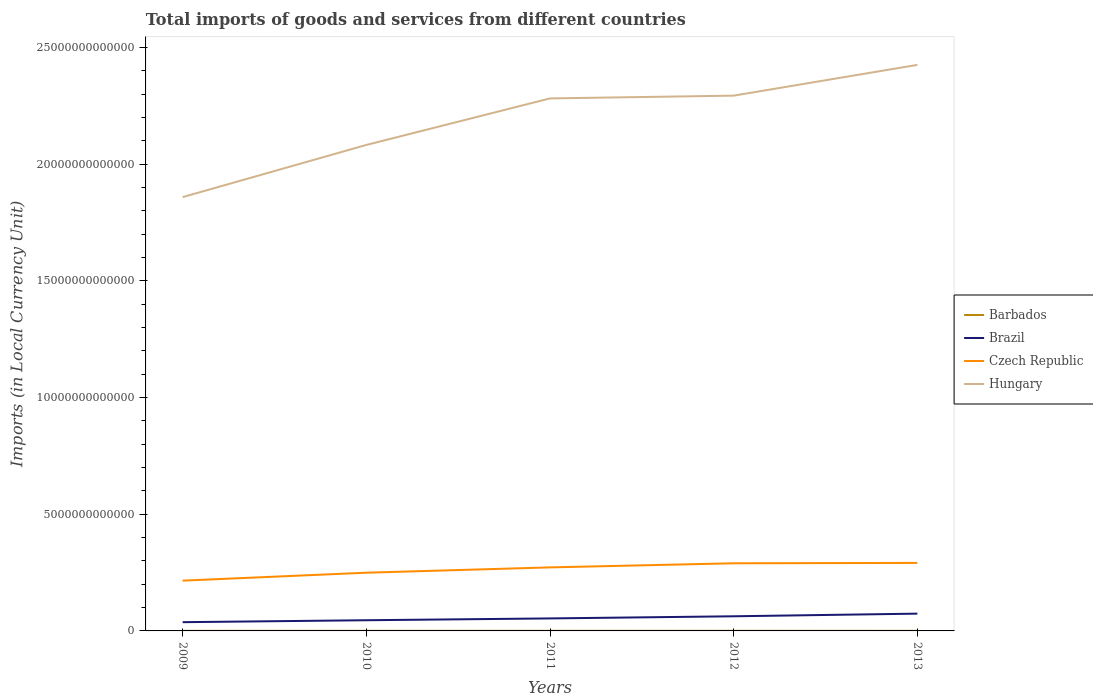Is the number of lines equal to the number of legend labels?
Provide a short and direct response. Yes. Across all years, what is the maximum Amount of goods and services imports in Brazil?
Ensure brevity in your answer.  3.75e+11. In which year was the Amount of goods and services imports in Czech Republic maximum?
Offer a very short reply. 2009. What is the total Amount of goods and services imports in Brazil in the graph?
Make the answer very short. -9.18e+1. What is the difference between the highest and the second highest Amount of goods and services imports in Czech Republic?
Keep it short and to the point. 7.60e+11. What is the difference between the highest and the lowest Amount of goods and services imports in Brazil?
Ensure brevity in your answer.  2. Is the Amount of goods and services imports in Hungary strictly greater than the Amount of goods and services imports in Czech Republic over the years?
Your answer should be compact. No. How many lines are there?
Your response must be concise. 4. How many years are there in the graph?
Ensure brevity in your answer.  5. What is the difference between two consecutive major ticks on the Y-axis?
Make the answer very short. 5.00e+12. Where does the legend appear in the graph?
Offer a very short reply. Center right. How many legend labels are there?
Offer a very short reply. 4. How are the legend labels stacked?
Keep it short and to the point. Vertical. What is the title of the graph?
Your answer should be very brief. Total imports of goods and services from different countries. What is the label or title of the X-axis?
Provide a short and direct response. Years. What is the label or title of the Y-axis?
Your answer should be compact. Imports (in Local Currency Unit). What is the Imports (in Local Currency Unit) in Barbados in 2009?
Provide a succinct answer. 4.09e+09. What is the Imports (in Local Currency Unit) of Brazil in 2009?
Keep it short and to the point. 3.75e+11. What is the Imports (in Local Currency Unit) in Czech Republic in 2009?
Your response must be concise. 2.15e+12. What is the Imports (in Local Currency Unit) of Hungary in 2009?
Provide a short and direct response. 1.86e+13. What is the Imports (in Local Currency Unit) of Barbados in 2010?
Give a very brief answer. 4.48e+09. What is the Imports (in Local Currency Unit) of Brazil in 2010?
Your response must be concise. 4.58e+11. What is the Imports (in Local Currency Unit) of Czech Republic in 2010?
Offer a terse response. 2.49e+12. What is the Imports (in Local Currency Unit) in Hungary in 2010?
Your answer should be very brief. 2.08e+13. What is the Imports (in Local Currency Unit) in Barbados in 2011?
Your response must be concise. 4.57e+09. What is the Imports (in Local Currency Unit) of Brazil in 2011?
Ensure brevity in your answer.  5.35e+11. What is the Imports (in Local Currency Unit) of Czech Republic in 2011?
Your answer should be compact. 2.72e+12. What is the Imports (in Local Currency Unit) in Hungary in 2011?
Provide a short and direct response. 2.28e+13. What is the Imports (in Local Currency Unit) in Barbados in 2012?
Provide a short and direct response. 4.35e+09. What is the Imports (in Local Currency Unit) in Brazil in 2012?
Offer a very short reply. 6.27e+11. What is the Imports (in Local Currency Unit) of Czech Republic in 2012?
Give a very brief answer. 2.90e+12. What is the Imports (in Local Currency Unit) in Hungary in 2012?
Your answer should be very brief. 2.29e+13. What is the Imports (in Local Currency Unit) in Barbados in 2013?
Give a very brief answer. 4.27e+09. What is the Imports (in Local Currency Unit) of Brazil in 2013?
Your answer should be compact. 7.40e+11. What is the Imports (in Local Currency Unit) of Czech Republic in 2013?
Offer a terse response. 2.91e+12. What is the Imports (in Local Currency Unit) of Hungary in 2013?
Provide a succinct answer. 2.42e+13. Across all years, what is the maximum Imports (in Local Currency Unit) of Barbados?
Provide a short and direct response. 4.57e+09. Across all years, what is the maximum Imports (in Local Currency Unit) of Brazil?
Keep it short and to the point. 7.40e+11. Across all years, what is the maximum Imports (in Local Currency Unit) of Czech Republic?
Make the answer very short. 2.91e+12. Across all years, what is the maximum Imports (in Local Currency Unit) in Hungary?
Your response must be concise. 2.42e+13. Across all years, what is the minimum Imports (in Local Currency Unit) in Barbados?
Give a very brief answer. 4.09e+09. Across all years, what is the minimum Imports (in Local Currency Unit) in Brazil?
Give a very brief answer. 3.75e+11. Across all years, what is the minimum Imports (in Local Currency Unit) in Czech Republic?
Give a very brief answer. 2.15e+12. Across all years, what is the minimum Imports (in Local Currency Unit) of Hungary?
Offer a very short reply. 1.86e+13. What is the total Imports (in Local Currency Unit) of Barbados in the graph?
Give a very brief answer. 2.18e+1. What is the total Imports (in Local Currency Unit) of Brazil in the graph?
Give a very brief answer. 2.74e+12. What is the total Imports (in Local Currency Unit) in Czech Republic in the graph?
Provide a succinct answer. 1.32e+13. What is the total Imports (in Local Currency Unit) of Hungary in the graph?
Keep it short and to the point. 1.09e+14. What is the difference between the Imports (in Local Currency Unit) of Barbados in 2009 and that in 2010?
Your answer should be very brief. -3.89e+08. What is the difference between the Imports (in Local Currency Unit) of Brazil in 2009 and that in 2010?
Your answer should be compact. -8.26e+1. What is the difference between the Imports (in Local Currency Unit) of Czech Republic in 2009 and that in 2010?
Your response must be concise. -3.40e+11. What is the difference between the Imports (in Local Currency Unit) of Hungary in 2009 and that in 2010?
Keep it short and to the point. -2.23e+12. What is the difference between the Imports (in Local Currency Unit) in Barbados in 2009 and that in 2011?
Ensure brevity in your answer.  -4.83e+08. What is the difference between the Imports (in Local Currency Unit) in Brazil in 2009 and that in 2011?
Ensure brevity in your answer.  -1.60e+11. What is the difference between the Imports (in Local Currency Unit) of Czech Republic in 2009 and that in 2011?
Provide a succinct answer. -5.68e+11. What is the difference between the Imports (in Local Currency Unit) of Hungary in 2009 and that in 2011?
Give a very brief answer. -4.23e+12. What is the difference between the Imports (in Local Currency Unit) of Barbados in 2009 and that in 2012?
Provide a succinct answer. -2.60e+08. What is the difference between the Imports (in Local Currency Unit) of Brazil in 2009 and that in 2012?
Offer a terse response. -2.52e+11. What is the difference between the Imports (in Local Currency Unit) of Czech Republic in 2009 and that in 2012?
Ensure brevity in your answer.  -7.43e+11. What is the difference between the Imports (in Local Currency Unit) in Hungary in 2009 and that in 2012?
Your response must be concise. -4.35e+12. What is the difference between the Imports (in Local Currency Unit) of Barbados in 2009 and that in 2013?
Your response must be concise. -1.83e+08. What is the difference between the Imports (in Local Currency Unit) of Brazil in 2009 and that in 2013?
Offer a very short reply. -3.65e+11. What is the difference between the Imports (in Local Currency Unit) of Czech Republic in 2009 and that in 2013?
Offer a terse response. -7.60e+11. What is the difference between the Imports (in Local Currency Unit) of Hungary in 2009 and that in 2013?
Ensure brevity in your answer.  -5.67e+12. What is the difference between the Imports (in Local Currency Unit) in Barbados in 2010 and that in 2011?
Offer a very short reply. -9.40e+07. What is the difference between the Imports (in Local Currency Unit) in Brazil in 2010 and that in 2011?
Offer a terse response. -7.78e+1. What is the difference between the Imports (in Local Currency Unit) of Czech Republic in 2010 and that in 2011?
Offer a terse response. -2.28e+11. What is the difference between the Imports (in Local Currency Unit) in Hungary in 2010 and that in 2011?
Keep it short and to the point. -1.99e+12. What is the difference between the Imports (in Local Currency Unit) of Barbados in 2010 and that in 2012?
Ensure brevity in your answer.  1.29e+08. What is the difference between the Imports (in Local Currency Unit) of Brazil in 2010 and that in 2012?
Your response must be concise. -1.70e+11. What is the difference between the Imports (in Local Currency Unit) of Czech Republic in 2010 and that in 2012?
Make the answer very short. -4.04e+11. What is the difference between the Imports (in Local Currency Unit) of Hungary in 2010 and that in 2012?
Ensure brevity in your answer.  -2.11e+12. What is the difference between the Imports (in Local Currency Unit) in Barbados in 2010 and that in 2013?
Your response must be concise. 2.06e+08. What is the difference between the Imports (in Local Currency Unit) in Brazil in 2010 and that in 2013?
Make the answer very short. -2.83e+11. What is the difference between the Imports (in Local Currency Unit) of Czech Republic in 2010 and that in 2013?
Give a very brief answer. -4.20e+11. What is the difference between the Imports (in Local Currency Unit) in Hungary in 2010 and that in 2013?
Give a very brief answer. -3.43e+12. What is the difference between the Imports (in Local Currency Unit) in Barbados in 2011 and that in 2012?
Make the answer very short. 2.23e+08. What is the difference between the Imports (in Local Currency Unit) in Brazil in 2011 and that in 2012?
Make the answer very short. -9.18e+1. What is the difference between the Imports (in Local Currency Unit) of Czech Republic in 2011 and that in 2012?
Your answer should be very brief. -1.76e+11. What is the difference between the Imports (in Local Currency Unit) of Hungary in 2011 and that in 2012?
Make the answer very short. -1.19e+11. What is the difference between the Imports (in Local Currency Unit) of Barbados in 2011 and that in 2013?
Make the answer very short. 3.00e+08. What is the difference between the Imports (in Local Currency Unit) of Brazil in 2011 and that in 2013?
Ensure brevity in your answer.  -2.05e+11. What is the difference between the Imports (in Local Currency Unit) in Czech Republic in 2011 and that in 2013?
Your answer should be compact. -1.92e+11. What is the difference between the Imports (in Local Currency Unit) of Hungary in 2011 and that in 2013?
Ensure brevity in your answer.  -1.44e+12. What is the difference between the Imports (in Local Currency Unit) in Barbados in 2012 and that in 2013?
Keep it short and to the point. 7.70e+07. What is the difference between the Imports (in Local Currency Unit) of Brazil in 2012 and that in 2013?
Your answer should be compact. -1.13e+11. What is the difference between the Imports (in Local Currency Unit) in Czech Republic in 2012 and that in 2013?
Your answer should be very brief. -1.66e+1. What is the difference between the Imports (in Local Currency Unit) of Hungary in 2012 and that in 2013?
Ensure brevity in your answer.  -1.32e+12. What is the difference between the Imports (in Local Currency Unit) in Barbados in 2009 and the Imports (in Local Currency Unit) in Brazil in 2010?
Offer a very short reply. -4.54e+11. What is the difference between the Imports (in Local Currency Unit) of Barbados in 2009 and the Imports (in Local Currency Unit) of Czech Republic in 2010?
Offer a terse response. -2.49e+12. What is the difference between the Imports (in Local Currency Unit) in Barbados in 2009 and the Imports (in Local Currency Unit) in Hungary in 2010?
Ensure brevity in your answer.  -2.08e+13. What is the difference between the Imports (in Local Currency Unit) in Brazil in 2009 and the Imports (in Local Currency Unit) in Czech Republic in 2010?
Give a very brief answer. -2.12e+12. What is the difference between the Imports (in Local Currency Unit) of Brazil in 2009 and the Imports (in Local Currency Unit) of Hungary in 2010?
Offer a very short reply. -2.04e+13. What is the difference between the Imports (in Local Currency Unit) in Czech Republic in 2009 and the Imports (in Local Currency Unit) in Hungary in 2010?
Keep it short and to the point. -1.87e+13. What is the difference between the Imports (in Local Currency Unit) in Barbados in 2009 and the Imports (in Local Currency Unit) in Brazil in 2011?
Offer a terse response. -5.31e+11. What is the difference between the Imports (in Local Currency Unit) of Barbados in 2009 and the Imports (in Local Currency Unit) of Czech Republic in 2011?
Provide a succinct answer. -2.72e+12. What is the difference between the Imports (in Local Currency Unit) of Barbados in 2009 and the Imports (in Local Currency Unit) of Hungary in 2011?
Provide a short and direct response. -2.28e+13. What is the difference between the Imports (in Local Currency Unit) of Brazil in 2009 and the Imports (in Local Currency Unit) of Czech Republic in 2011?
Offer a terse response. -2.35e+12. What is the difference between the Imports (in Local Currency Unit) of Brazil in 2009 and the Imports (in Local Currency Unit) of Hungary in 2011?
Keep it short and to the point. -2.24e+13. What is the difference between the Imports (in Local Currency Unit) in Czech Republic in 2009 and the Imports (in Local Currency Unit) in Hungary in 2011?
Offer a terse response. -2.07e+13. What is the difference between the Imports (in Local Currency Unit) of Barbados in 2009 and the Imports (in Local Currency Unit) of Brazil in 2012?
Provide a short and direct response. -6.23e+11. What is the difference between the Imports (in Local Currency Unit) of Barbados in 2009 and the Imports (in Local Currency Unit) of Czech Republic in 2012?
Your response must be concise. -2.89e+12. What is the difference between the Imports (in Local Currency Unit) in Barbados in 2009 and the Imports (in Local Currency Unit) in Hungary in 2012?
Your answer should be very brief. -2.29e+13. What is the difference between the Imports (in Local Currency Unit) in Brazil in 2009 and the Imports (in Local Currency Unit) in Czech Republic in 2012?
Keep it short and to the point. -2.52e+12. What is the difference between the Imports (in Local Currency Unit) of Brazil in 2009 and the Imports (in Local Currency Unit) of Hungary in 2012?
Ensure brevity in your answer.  -2.26e+13. What is the difference between the Imports (in Local Currency Unit) in Czech Republic in 2009 and the Imports (in Local Currency Unit) in Hungary in 2012?
Offer a very short reply. -2.08e+13. What is the difference between the Imports (in Local Currency Unit) of Barbados in 2009 and the Imports (in Local Currency Unit) of Brazil in 2013?
Make the answer very short. -7.36e+11. What is the difference between the Imports (in Local Currency Unit) in Barbados in 2009 and the Imports (in Local Currency Unit) in Czech Republic in 2013?
Your answer should be compact. -2.91e+12. What is the difference between the Imports (in Local Currency Unit) of Barbados in 2009 and the Imports (in Local Currency Unit) of Hungary in 2013?
Make the answer very short. -2.42e+13. What is the difference between the Imports (in Local Currency Unit) in Brazil in 2009 and the Imports (in Local Currency Unit) in Czech Republic in 2013?
Your response must be concise. -2.54e+12. What is the difference between the Imports (in Local Currency Unit) of Brazil in 2009 and the Imports (in Local Currency Unit) of Hungary in 2013?
Make the answer very short. -2.39e+13. What is the difference between the Imports (in Local Currency Unit) of Czech Republic in 2009 and the Imports (in Local Currency Unit) of Hungary in 2013?
Your answer should be very brief. -2.21e+13. What is the difference between the Imports (in Local Currency Unit) of Barbados in 2010 and the Imports (in Local Currency Unit) of Brazil in 2011?
Provide a short and direct response. -5.31e+11. What is the difference between the Imports (in Local Currency Unit) in Barbados in 2010 and the Imports (in Local Currency Unit) in Czech Republic in 2011?
Provide a short and direct response. -2.72e+12. What is the difference between the Imports (in Local Currency Unit) of Barbados in 2010 and the Imports (in Local Currency Unit) of Hungary in 2011?
Make the answer very short. -2.28e+13. What is the difference between the Imports (in Local Currency Unit) in Brazil in 2010 and the Imports (in Local Currency Unit) in Czech Republic in 2011?
Keep it short and to the point. -2.26e+12. What is the difference between the Imports (in Local Currency Unit) in Brazil in 2010 and the Imports (in Local Currency Unit) in Hungary in 2011?
Offer a very short reply. -2.24e+13. What is the difference between the Imports (in Local Currency Unit) in Czech Republic in 2010 and the Imports (in Local Currency Unit) in Hungary in 2011?
Your answer should be very brief. -2.03e+13. What is the difference between the Imports (in Local Currency Unit) in Barbados in 2010 and the Imports (in Local Currency Unit) in Brazil in 2012?
Offer a terse response. -6.23e+11. What is the difference between the Imports (in Local Currency Unit) of Barbados in 2010 and the Imports (in Local Currency Unit) of Czech Republic in 2012?
Provide a short and direct response. -2.89e+12. What is the difference between the Imports (in Local Currency Unit) of Barbados in 2010 and the Imports (in Local Currency Unit) of Hungary in 2012?
Your response must be concise. -2.29e+13. What is the difference between the Imports (in Local Currency Unit) of Brazil in 2010 and the Imports (in Local Currency Unit) of Czech Republic in 2012?
Your response must be concise. -2.44e+12. What is the difference between the Imports (in Local Currency Unit) of Brazil in 2010 and the Imports (in Local Currency Unit) of Hungary in 2012?
Provide a succinct answer. -2.25e+13. What is the difference between the Imports (in Local Currency Unit) in Czech Republic in 2010 and the Imports (in Local Currency Unit) in Hungary in 2012?
Give a very brief answer. -2.04e+13. What is the difference between the Imports (in Local Currency Unit) in Barbados in 2010 and the Imports (in Local Currency Unit) in Brazil in 2013?
Provide a succinct answer. -7.36e+11. What is the difference between the Imports (in Local Currency Unit) in Barbados in 2010 and the Imports (in Local Currency Unit) in Czech Republic in 2013?
Provide a succinct answer. -2.91e+12. What is the difference between the Imports (in Local Currency Unit) of Barbados in 2010 and the Imports (in Local Currency Unit) of Hungary in 2013?
Your answer should be very brief. -2.42e+13. What is the difference between the Imports (in Local Currency Unit) in Brazil in 2010 and the Imports (in Local Currency Unit) in Czech Republic in 2013?
Your response must be concise. -2.46e+12. What is the difference between the Imports (in Local Currency Unit) in Brazil in 2010 and the Imports (in Local Currency Unit) in Hungary in 2013?
Make the answer very short. -2.38e+13. What is the difference between the Imports (in Local Currency Unit) of Czech Republic in 2010 and the Imports (in Local Currency Unit) of Hungary in 2013?
Offer a terse response. -2.18e+13. What is the difference between the Imports (in Local Currency Unit) of Barbados in 2011 and the Imports (in Local Currency Unit) of Brazil in 2012?
Your response must be concise. -6.23e+11. What is the difference between the Imports (in Local Currency Unit) of Barbados in 2011 and the Imports (in Local Currency Unit) of Czech Republic in 2012?
Make the answer very short. -2.89e+12. What is the difference between the Imports (in Local Currency Unit) of Barbados in 2011 and the Imports (in Local Currency Unit) of Hungary in 2012?
Keep it short and to the point. -2.29e+13. What is the difference between the Imports (in Local Currency Unit) in Brazil in 2011 and the Imports (in Local Currency Unit) in Czech Republic in 2012?
Offer a very short reply. -2.36e+12. What is the difference between the Imports (in Local Currency Unit) in Brazil in 2011 and the Imports (in Local Currency Unit) in Hungary in 2012?
Give a very brief answer. -2.24e+13. What is the difference between the Imports (in Local Currency Unit) in Czech Republic in 2011 and the Imports (in Local Currency Unit) in Hungary in 2012?
Give a very brief answer. -2.02e+13. What is the difference between the Imports (in Local Currency Unit) in Barbados in 2011 and the Imports (in Local Currency Unit) in Brazil in 2013?
Your answer should be very brief. -7.36e+11. What is the difference between the Imports (in Local Currency Unit) of Barbados in 2011 and the Imports (in Local Currency Unit) of Czech Republic in 2013?
Provide a succinct answer. -2.91e+12. What is the difference between the Imports (in Local Currency Unit) in Barbados in 2011 and the Imports (in Local Currency Unit) in Hungary in 2013?
Provide a short and direct response. -2.42e+13. What is the difference between the Imports (in Local Currency Unit) of Brazil in 2011 and the Imports (in Local Currency Unit) of Czech Republic in 2013?
Offer a terse response. -2.38e+12. What is the difference between the Imports (in Local Currency Unit) in Brazil in 2011 and the Imports (in Local Currency Unit) in Hungary in 2013?
Ensure brevity in your answer.  -2.37e+13. What is the difference between the Imports (in Local Currency Unit) of Czech Republic in 2011 and the Imports (in Local Currency Unit) of Hungary in 2013?
Your response must be concise. -2.15e+13. What is the difference between the Imports (in Local Currency Unit) in Barbados in 2012 and the Imports (in Local Currency Unit) in Brazil in 2013?
Ensure brevity in your answer.  -7.36e+11. What is the difference between the Imports (in Local Currency Unit) in Barbados in 2012 and the Imports (in Local Currency Unit) in Czech Republic in 2013?
Provide a succinct answer. -2.91e+12. What is the difference between the Imports (in Local Currency Unit) of Barbados in 2012 and the Imports (in Local Currency Unit) of Hungary in 2013?
Make the answer very short. -2.42e+13. What is the difference between the Imports (in Local Currency Unit) of Brazil in 2012 and the Imports (in Local Currency Unit) of Czech Republic in 2013?
Your answer should be very brief. -2.29e+12. What is the difference between the Imports (in Local Currency Unit) in Brazil in 2012 and the Imports (in Local Currency Unit) in Hungary in 2013?
Your answer should be compact. -2.36e+13. What is the difference between the Imports (in Local Currency Unit) of Czech Republic in 2012 and the Imports (in Local Currency Unit) of Hungary in 2013?
Offer a very short reply. -2.14e+13. What is the average Imports (in Local Currency Unit) of Barbados per year?
Provide a short and direct response. 4.35e+09. What is the average Imports (in Local Currency Unit) in Brazil per year?
Make the answer very short. 5.47e+11. What is the average Imports (in Local Currency Unit) in Czech Republic per year?
Provide a short and direct response. 2.64e+12. What is the average Imports (in Local Currency Unit) in Hungary per year?
Provide a short and direct response. 2.19e+13. In the year 2009, what is the difference between the Imports (in Local Currency Unit) of Barbados and Imports (in Local Currency Unit) of Brazil?
Provide a short and direct response. -3.71e+11. In the year 2009, what is the difference between the Imports (in Local Currency Unit) of Barbados and Imports (in Local Currency Unit) of Czech Republic?
Keep it short and to the point. -2.15e+12. In the year 2009, what is the difference between the Imports (in Local Currency Unit) in Barbados and Imports (in Local Currency Unit) in Hungary?
Keep it short and to the point. -1.86e+13. In the year 2009, what is the difference between the Imports (in Local Currency Unit) of Brazil and Imports (in Local Currency Unit) of Czech Republic?
Ensure brevity in your answer.  -1.78e+12. In the year 2009, what is the difference between the Imports (in Local Currency Unit) of Brazil and Imports (in Local Currency Unit) of Hungary?
Keep it short and to the point. -1.82e+13. In the year 2009, what is the difference between the Imports (in Local Currency Unit) in Czech Republic and Imports (in Local Currency Unit) in Hungary?
Offer a terse response. -1.64e+13. In the year 2010, what is the difference between the Imports (in Local Currency Unit) in Barbados and Imports (in Local Currency Unit) in Brazil?
Provide a short and direct response. -4.53e+11. In the year 2010, what is the difference between the Imports (in Local Currency Unit) in Barbados and Imports (in Local Currency Unit) in Czech Republic?
Give a very brief answer. -2.49e+12. In the year 2010, what is the difference between the Imports (in Local Currency Unit) in Barbados and Imports (in Local Currency Unit) in Hungary?
Provide a succinct answer. -2.08e+13. In the year 2010, what is the difference between the Imports (in Local Currency Unit) of Brazil and Imports (in Local Currency Unit) of Czech Republic?
Offer a very short reply. -2.04e+12. In the year 2010, what is the difference between the Imports (in Local Currency Unit) of Brazil and Imports (in Local Currency Unit) of Hungary?
Offer a terse response. -2.04e+13. In the year 2010, what is the difference between the Imports (in Local Currency Unit) in Czech Republic and Imports (in Local Currency Unit) in Hungary?
Provide a succinct answer. -1.83e+13. In the year 2011, what is the difference between the Imports (in Local Currency Unit) in Barbados and Imports (in Local Currency Unit) in Brazil?
Make the answer very short. -5.31e+11. In the year 2011, what is the difference between the Imports (in Local Currency Unit) of Barbados and Imports (in Local Currency Unit) of Czech Republic?
Provide a short and direct response. -2.72e+12. In the year 2011, what is the difference between the Imports (in Local Currency Unit) in Barbados and Imports (in Local Currency Unit) in Hungary?
Keep it short and to the point. -2.28e+13. In the year 2011, what is the difference between the Imports (in Local Currency Unit) in Brazil and Imports (in Local Currency Unit) in Czech Republic?
Your response must be concise. -2.19e+12. In the year 2011, what is the difference between the Imports (in Local Currency Unit) of Brazil and Imports (in Local Currency Unit) of Hungary?
Provide a short and direct response. -2.23e+13. In the year 2011, what is the difference between the Imports (in Local Currency Unit) of Czech Republic and Imports (in Local Currency Unit) of Hungary?
Make the answer very short. -2.01e+13. In the year 2012, what is the difference between the Imports (in Local Currency Unit) of Barbados and Imports (in Local Currency Unit) of Brazil?
Offer a very short reply. -6.23e+11. In the year 2012, what is the difference between the Imports (in Local Currency Unit) of Barbados and Imports (in Local Currency Unit) of Czech Republic?
Provide a succinct answer. -2.89e+12. In the year 2012, what is the difference between the Imports (in Local Currency Unit) in Barbados and Imports (in Local Currency Unit) in Hungary?
Offer a very short reply. -2.29e+13. In the year 2012, what is the difference between the Imports (in Local Currency Unit) in Brazil and Imports (in Local Currency Unit) in Czech Republic?
Your answer should be compact. -2.27e+12. In the year 2012, what is the difference between the Imports (in Local Currency Unit) in Brazil and Imports (in Local Currency Unit) in Hungary?
Make the answer very short. -2.23e+13. In the year 2012, what is the difference between the Imports (in Local Currency Unit) in Czech Republic and Imports (in Local Currency Unit) in Hungary?
Make the answer very short. -2.00e+13. In the year 2013, what is the difference between the Imports (in Local Currency Unit) in Barbados and Imports (in Local Currency Unit) in Brazil?
Make the answer very short. -7.36e+11. In the year 2013, what is the difference between the Imports (in Local Currency Unit) of Barbados and Imports (in Local Currency Unit) of Czech Republic?
Your answer should be compact. -2.91e+12. In the year 2013, what is the difference between the Imports (in Local Currency Unit) in Barbados and Imports (in Local Currency Unit) in Hungary?
Give a very brief answer. -2.42e+13. In the year 2013, what is the difference between the Imports (in Local Currency Unit) of Brazil and Imports (in Local Currency Unit) of Czech Republic?
Your answer should be very brief. -2.17e+12. In the year 2013, what is the difference between the Imports (in Local Currency Unit) in Brazil and Imports (in Local Currency Unit) in Hungary?
Your response must be concise. -2.35e+13. In the year 2013, what is the difference between the Imports (in Local Currency Unit) of Czech Republic and Imports (in Local Currency Unit) of Hungary?
Ensure brevity in your answer.  -2.13e+13. What is the ratio of the Imports (in Local Currency Unit) of Barbados in 2009 to that in 2010?
Your answer should be compact. 0.91. What is the ratio of the Imports (in Local Currency Unit) of Brazil in 2009 to that in 2010?
Give a very brief answer. 0.82. What is the ratio of the Imports (in Local Currency Unit) in Czech Republic in 2009 to that in 2010?
Make the answer very short. 0.86. What is the ratio of the Imports (in Local Currency Unit) of Hungary in 2009 to that in 2010?
Provide a short and direct response. 0.89. What is the ratio of the Imports (in Local Currency Unit) of Barbados in 2009 to that in 2011?
Offer a very short reply. 0.89. What is the ratio of the Imports (in Local Currency Unit) of Brazil in 2009 to that in 2011?
Keep it short and to the point. 0.7. What is the ratio of the Imports (in Local Currency Unit) of Czech Republic in 2009 to that in 2011?
Keep it short and to the point. 0.79. What is the ratio of the Imports (in Local Currency Unit) in Hungary in 2009 to that in 2011?
Offer a terse response. 0.81. What is the ratio of the Imports (in Local Currency Unit) of Barbados in 2009 to that in 2012?
Make the answer very short. 0.94. What is the ratio of the Imports (in Local Currency Unit) of Brazil in 2009 to that in 2012?
Make the answer very short. 0.6. What is the ratio of the Imports (in Local Currency Unit) in Czech Republic in 2009 to that in 2012?
Your response must be concise. 0.74. What is the ratio of the Imports (in Local Currency Unit) in Hungary in 2009 to that in 2012?
Provide a short and direct response. 0.81. What is the ratio of the Imports (in Local Currency Unit) in Barbados in 2009 to that in 2013?
Offer a very short reply. 0.96. What is the ratio of the Imports (in Local Currency Unit) in Brazil in 2009 to that in 2013?
Ensure brevity in your answer.  0.51. What is the ratio of the Imports (in Local Currency Unit) in Czech Republic in 2009 to that in 2013?
Offer a terse response. 0.74. What is the ratio of the Imports (in Local Currency Unit) of Hungary in 2009 to that in 2013?
Give a very brief answer. 0.77. What is the ratio of the Imports (in Local Currency Unit) of Barbados in 2010 to that in 2011?
Provide a succinct answer. 0.98. What is the ratio of the Imports (in Local Currency Unit) in Brazil in 2010 to that in 2011?
Your response must be concise. 0.85. What is the ratio of the Imports (in Local Currency Unit) in Czech Republic in 2010 to that in 2011?
Provide a short and direct response. 0.92. What is the ratio of the Imports (in Local Currency Unit) of Hungary in 2010 to that in 2011?
Your response must be concise. 0.91. What is the ratio of the Imports (in Local Currency Unit) in Barbados in 2010 to that in 2012?
Offer a very short reply. 1.03. What is the ratio of the Imports (in Local Currency Unit) in Brazil in 2010 to that in 2012?
Give a very brief answer. 0.73. What is the ratio of the Imports (in Local Currency Unit) of Czech Republic in 2010 to that in 2012?
Keep it short and to the point. 0.86. What is the ratio of the Imports (in Local Currency Unit) of Hungary in 2010 to that in 2012?
Your answer should be very brief. 0.91. What is the ratio of the Imports (in Local Currency Unit) in Barbados in 2010 to that in 2013?
Your answer should be very brief. 1.05. What is the ratio of the Imports (in Local Currency Unit) of Brazil in 2010 to that in 2013?
Make the answer very short. 0.62. What is the ratio of the Imports (in Local Currency Unit) in Czech Republic in 2010 to that in 2013?
Your answer should be very brief. 0.86. What is the ratio of the Imports (in Local Currency Unit) of Hungary in 2010 to that in 2013?
Your answer should be compact. 0.86. What is the ratio of the Imports (in Local Currency Unit) of Barbados in 2011 to that in 2012?
Provide a succinct answer. 1.05. What is the ratio of the Imports (in Local Currency Unit) in Brazil in 2011 to that in 2012?
Keep it short and to the point. 0.85. What is the ratio of the Imports (in Local Currency Unit) of Czech Republic in 2011 to that in 2012?
Provide a short and direct response. 0.94. What is the ratio of the Imports (in Local Currency Unit) in Hungary in 2011 to that in 2012?
Offer a very short reply. 0.99. What is the ratio of the Imports (in Local Currency Unit) in Barbados in 2011 to that in 2013?
Provide a short and direct response. 1.07. What is the ratio of the Imports (in Local Currency Unit) in Brazil in 2011 to that in 2013?
Give a very brief answer. 0.72. What is the ratio of the Imports (in Local Currency Unit) of Czech Republic in 2011 to that in 2013?
Provide a succinct answer. 0.93. What is the ratio of the Imports (in Local Currency Unit) of Hungary in 2011 to that in 2013?
Give a very brief answer. 0.94. What is the ratio of the Imports (in Local Currency Unit) in Barbados in 2012 to that in 2013?
Ensure brevity in your answer.  1.02. What is the ratio of the Imports (in Local Currency Unit) of Brazil in 2012 to that in 2013?
Offer a terse response. 0.85. What is the ratio of the Imports (in Local Currency Unit) of Czech Republic in 2012 to that in 2013?
Offer a very short reply. 0.99. What is the ratio of the Imports (in Local Currency Unit) in Hungary in 2012 to that in 2013?
Offer a very short reply. 0.95. What is the difference between the highest and the second highest Imports (in Local Currency Unit) of Barbados?
Make the answer very short. 9.40e+07. What is the difference between the highest and the second highest Imports (in Local Currency Unit) of Brazil?
Offer a very short reply. 1.13e+11. What is the difference between the highest and the second highest Imports (in Local Currency Unit) in Czech Republic?
Your answer should be very brief. 1.66e+1. What is the difference between the highest and the second highest Imports (in Local Currency Unit) in Hungary?
Keep it short and to the point. 1.32e+12. What is the difference between the highest and the lowest Imports (in Local Currency Unit) of Barbados?
Give a very brief answer. 4.83e+08. What is the difference between the highest and the lowest Imports (in Local Currency Unit) of Brazil?
Keep it short and to the point. 3.65e+11. What is the difference between the highest and the lowest Imports (in Local Currency Unit) in Czech Republic?
Your answer should be compact. 7.60e+11. What is the difference between the highest and the lowest Imports (in Local Currency Unit) in Hungary?
Keep it short and to the point. 5.67e+12. 